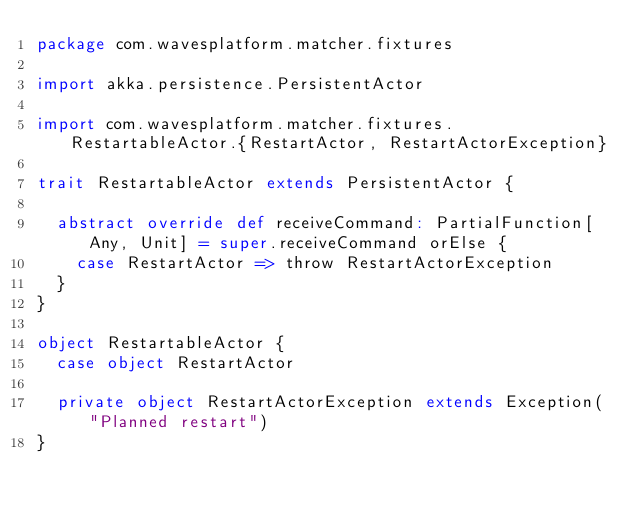<code> <loc_0><loc_0><loc_500><loc_500><_Scala_>package com.wavesplatform.matcher.fixtures

import akka.persistence.PersistentActor

import com.wavesplatform.matcher.fixtures.RestartableActor.{RestartActor, RestartActorException}

trait RestartableActor extends PersistentActor {

  abstract override def receiveCommand: PartialFunction[Any, Unit] = super.receiveCommand orElse {
    case RestartActor => throw RestartActorException
  }
}

object RestartableActor {
  case object RestartActor

  private object RestartActorException extends Exception("Planned restart")
}
</code> 